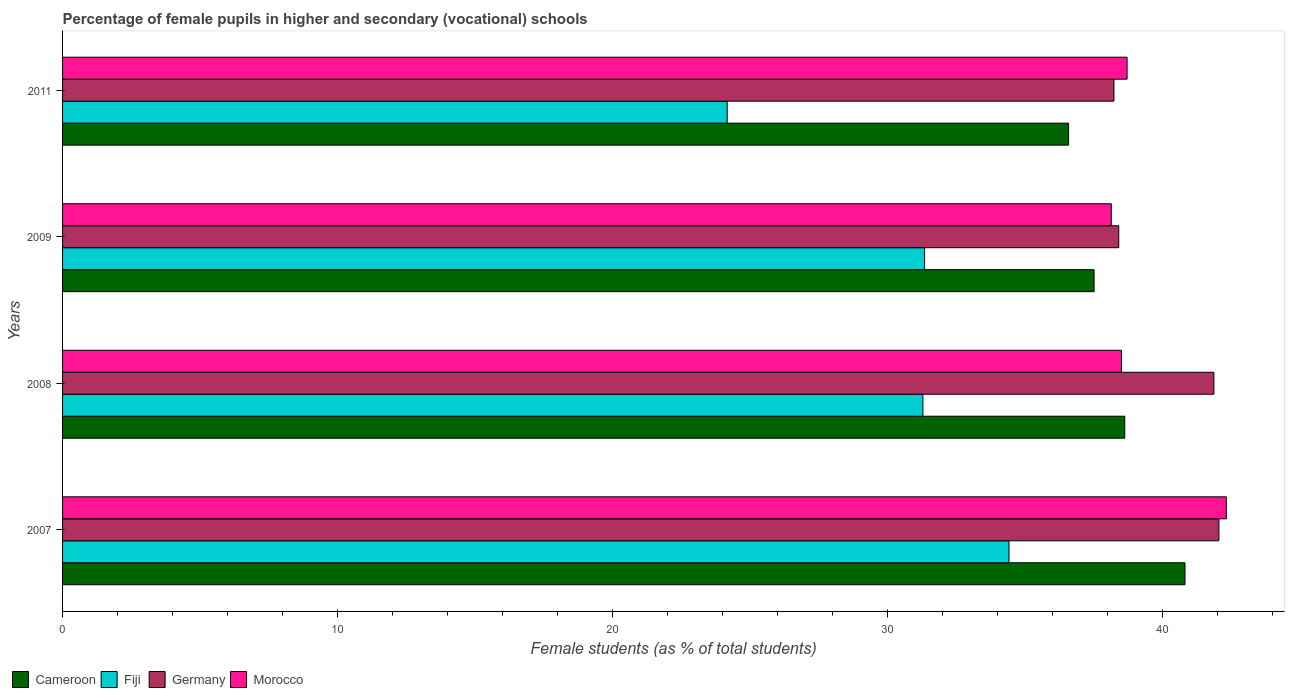How many different coloured bars are there?
Your response must be concise. 4. How many groups of bars are there?
Make the answer very short. 4. How many bars are there on the 1st tick from the bottom?
Offer a terse response. 4. In how many cases, is the number of bars for a given year not equal to the number of legend labels?
Provide a succinct answer. 0. What is the percentage of female pupils in higher and secondary schools in Germany in 2011?
Your answer should be very brief. 38.22. Across all years, what is the maximum percentage of female pupils in higher and secondary schools in Fiji?
Ensure brevity in your answer.  34.4. Across all years, what is the minimum percentage of female pupils in higher and secondary schools in Cameroon?
Ensure brevity in your answer.  36.57. What is the total percentage of female pupils in higher and secondary schools in Germany in the graph?
Make the answer very short. 160.5. What is the difference between the percentage of female pupils in higher and secondary schools in Morocco in 2009 and that in 2011?
Give a very brief answer. -0.57. What is the difference between the percentage of female pupils in higher and secondary schools in Fiji in 2009 and the percentage of female pupils in higher and secondary schools in Cameroon in 2007?
Provide a short and direct response. -9.47. What is the average percentage of female pupils in higher and secondary schools in Fiji per year?
Provide a short and direct response. 30.29. In the year 2007, what is the difference between the percentage of female pupils in higher and secondary schools in Germany and percentage of female pupils in higher and secondary schools in Cameroon?
Ensure brevity in your answer.  1.23. What is the ratio of the percentage of female pupils in higher and secondary schools in Morocco in 2007 to that in 2011?
Your answer should be very brief. 1.09. Is the percentage of female pupils in higher and secondary schools in Morocco in 2009 less than that in 2011?
Give a very brief answer. Yes. What is the difference between the highest and the second highest percentage of female pupils in higher and secondary schools in Fiji?
Provide a succinct answer. 3.07. What is the difference between the highest and the lowest percentage of female pupils in higher and secondary schools in Germany?
Provide a short and direct response. 3.82. What does the 1st bar from the top in 2007 represents?
Your answer should be compact. Morocco. What does the 4th bar from the bottom in 2007 represents?
Provide a succinct answer. Morocco. Is it the case that in every year, the sum of the percentage of female pupils in higher and secondary schools in Cameroon and percentage of female pupils in higher and secondary schools in Morocco is greater than the percentage of female pupils in higher and secondary schools in Germany?
Ensure brevity in your answer.  Yes. Are all the bars in the graph horizontal?
Offer a terse response. Yes. What is the difference between two consecutive major ticks on the X-axis?
Make the answer very short. 10. Are the values on the major ticks of X-axis written in scientific E-notation?
Give a very brief answer. No. How many legend labels are there?
Ensure brevity in your answer.  4. What is the title of the graph?
Keep it short and to the point. Percentage of female pupils in higher and secondary (vocational) schools. Does "Lower middle income" appear as one of the legend labels in the graph?
Provide a succinct answer. No. What is the label or title of the X-axis?
Your answer should be very brief. Female students (as % of total students). What is the label or title of the Y-axis?
Offer a terse response. Years. What is the Female students (as % of total students) of Cameroon in 2007?
Provide a short and direct response. 40.8. What is the Female students (as % of total students) in Fiji in 2007?
Your response must be concise. 34.4. What is the Female students (as % of total students) in Germany in 2007?
Ensure brevity in your answer.  42.04. What is the Female students (as % of total students) in Morocco in 2007?
Provide a succinct answer. 42.3. What is the Female students (as % of total students) in Cameroon in 2008?
Ensure brevity in your answer.  38.61. What is the Female students (as % of total students) in Fiji in 2008?
Provide a succinct answer. 31.27. What is the Female students (as % of total students) in Germany in 2008?
Your answer should be very brief. 41.85. What is the Female students (as % of total students) of Morocco in 2008?
Your response must be concise. 38.49. What is the Female students (as % of total students) of Cameroon in 2009?
Make the answer very short. 37.5. What is the Female students (as % of total students) of Fiji in 2009?
Your response must be concise. 31.34. What is the Female students (as % of total students) of Germany in 2009?
Make the answer very short. 38.39. What is the Female students (as % of total students) in Morocco in 2009?
Provide a short and direct response. 38.12. What is the Female students (as % of total students) of Cameroon in 2011?
Provide a short and direct response. 36.57. What is the Female students (as % of total students) of Fiji in 2011?
Provide a succinct answer. 24.16. What is the Female students (as % of total students) in Germany in 2011?
Give a very brief answer. 38.22. What is the Female students (as % of total students) in Morocco in 2011?
Your response must be concise. 38.7. Across all years, what is the maximum Female students (as % of total students) of Cameroon?
Make the answer very short. 40.8. Across all years, what is the maximum Female students (as % of total students) in Fiji?
Ensure brevity in your answer.  34.4. Across all years, what is the maximum Female students (as % of total students) in Germany?
Ensure brevity in your answer.  42.04. Across all years, what is the maximum Female students (as % of total students) of Morocco?
Provide a succinct answer. 42.3. Across all years, what is the minimum Female students (as % of total students) of Cameroon?
Ensure brevity in your answer.  36.57. Across all years, what is the minimum Female students (as % of total students) of Fiji?
Your response must be concise. 24.16. Across all years, what is the minimum Female students (as % of total students) in Germany?
Keep it short and to the point. 38.22. Across all years, what is the minimum Female students (as % of total students) in Morocco?
Your response must be concise. 38.12. What is the total Female students (as % of total students) of Cameroon in the graph?
Your answer should be compact. 153.48. What is the total Female students (as % of total students) of Fiji in the graph?
Offer a terse response. 121.18. What is the total Female students (as % of total students) of Germany in the graph?
Provide a short and direct response. 160.5. What is the total Female students (as % of total students) of Morocco in the graph?
Make the answer very short. 157.62. What is the difference between the Female students (as % of total students) in Cameroon in 2007 and that in 2008?
Your answer should be very brief. 2.19. What is the difference between the Female students (as % of total students) of Fiji in 2007 and that in 2008?
Provide a short and direct response. 3.13. What is the difference between the Female students (as % of total students) in Germany in 2007 and that in 2008?
Your response must be concise. 0.18. What is the difference between the Female students (as % of total students) in Morocco in 2007 and that in 2008?
Give a very brief answer. 3.81. What is the difference between the Female students (as % of total students) of Cameroon in 2007 and that in 2009?
Keep it short and to the point. 3.3. What is the difference between the Female students (as % of total students) in Fiji in 2007 and that in 2009?
Offer a very short reply. 3.07. What is the difference between the Female students (as % of total students) in Germany in 2007 and that in 2009?
Keep it short and to the point. 3.64. What is the difference between the Female students (as % of total students) in Morocco in 2007 and that in 2009?
Keep it short and to the point. 4.18. What is the difference between the Female students (as % of total students) in Cameroon in 2007 and that in 2011?
Offer a terse response. 4.23. What is the difference between the Female students (as % of total students) in Fiji in 2007 and that in 2011?
Ensure brevity in your answer.  10.24. What is the difference between the Female students (as % of total students) of Germany in 2007 and that in 2011?
Give a very brief answer. 3.82. What is the difference between the Female students (as % of total students) in Morocco in 2007 and that in 2011?
Ensure brevity in your answer.  3.61. What is the difference between the Female students (as % of total students) in Cameroon in 2008 and that in 2009?
Offer a terse response. 1.12. What is the difference between the Female students (as % of total students) of Fiji in 2008 and that in 2009?
Offer a terse response. -0.06. What is the difference between the Female students (as % of total students) of Germany in 2008 and that in 2009?
Your answer should be compact. 3.46. What is the difference between the Female students (as % of total students) of Morocco in 2008 and that in 2009?
Offer a terse response. 0.37. What is the difference between the Female students (as % of total students) of Cameroon in 2008 and that in 2011?
Your answer should be compact. 2.04. What is the difference between the Female students (as % of total students) in Fiji in 2008 and that in 2011?
Offer a terse response. 7.11. What is the difference between the Female students (as % of total students) of Germany in 2008 and that in 2011?
Offer a terse response. 3.63. What is the difference between the Female students (as % of total students) in Morocco in 2008 and that in 2011?
Make the answer very short. -0.2. What is the difference between the Female students (as % of total students) of Cameroon in 2009 and that in 2011?
Provide a short and direct response. 0.93. What is the difference between the Female students (as % of total students) in Fiji in 2009 and that in 2011?
Offer a terse response. 7.18. What is the difference between the Female students (as % of total students) of Germany in 2009 and that in 2011?
Provide a short and direct response. 0.17. What is the difference between the Female students (as % of total students) in Morocco in 2009 and that in 2011?
Provide a succinct answer. -0.57. What is the difference between the Female students (as % of total students) in Cameroon in 2007 and the Female students (as % of total students) in Fiji in 2008?
Offer a terse response. 9.53. What is the difference between the Female students (as % of total students) of Cameroon in 2007 and the Female students (as % of total students) of Germany in 2008?
Provide a short and direct response. -1.05. What is the difference between the Female students (as % of total students) of Cameroon in 2007 and the Female students (as % of total students) of Morocco in 2008?
Your response must be concise. 2.31. What is the difference between the Female students (as % of total students) of Fiji in 2007 and the Female students (as % of total students) of Germany in 2008?
Provide a succinct answer. -7.45. What is the difference between the Female students (as % of total students) of Fiji in 2007 and the Female students (as % of total students) of Morocco in 2008?
Your answer should be compact. -4.09. What is the difference between the Female students (as % of total students) of Germany in 2007 and the Female students (as % of total students) of Morocco in 2008?
Your answer should be very brief. 3.54. What is the difference between the Female students (as % of total students) of Cameroon in 2007 and the Female students (as % of total students) of Fiji in 2009?
Make the answer very short. 9.47. What is the difference between the Female students (as % of total students) of Cameroon in 2007 and the Female students (as % of total students) of Germany in 2009?
Your answer should be compact. 2.41. What is the difference between the Female students (as % of total students) of Cameroon in 2007 and the Female students (as % of total students) of Morocco in 2009?
Give a very brief answer. 2.68. What is the difference between the Female students (as % of total students) of Fiji in 2007 and the Female students (as % of total students) of Germany in 2009?
Offer a terse response. -3.99. What is the difference between the Female students (as % of total students) of Fiji in 2007 and the Female students (as % of total students) of Morocco in 2009?
Your answer should be very brief. -3.72. What is the difference between the Female students (as % of total students) in Germany in 2007 and the Female students (as % of total students) in Morocco in 2009?
Make the answer very short. 3.91. What is the difference between the Female students (as % of total students) of Cameroon in 2007 and the Female students (as % of total students) of Fiji in 2011?
Give a very brief answer. 16.64. What is the difference between the Female students (as % of total students) in Cameroon in 2007 and the Female students (as % of total students) in Germany in 2011?
Offer a terse response. 2.58. What is the difference between the Female students (as % of total students) in Cameroon in 2007 and the Female students (as % of total students) in Morocco in 2011?
Your response must be concise. 2.1. What is the difference between the Female students (as % of total students) of Fiji in 2007 and the Female students (as % of total students) of Germany in 2011?
Your response must be concise. -3.82. What is the difference between the Female students (as % of total students) in Fiji in 2007 and the Female students (as % of total students) in Morocco in 2011?
Offer a very short reply. -4.29. What is the difference between the Female students (as % of total students) in Germany in 2007 and the Female students (as % of total students) in Morocco in 2011?
Ensure brevity in your answer.  3.34. What is the difference between the Female students (as % of total students) in Cameroon in 2008 and the Female students (as % of total students) in Fiji in 2009?
Make the answer very short. 7.28. What is the difference between the Female students (as % of total students) in Cameroon in 2008 and the Female students (as % of total students) in Germany in 2009?
Offer a terse response. 0.22. What is the difference between the Female students (as % of total students) in Cameroon in 2008 and the Female students (as % of total students) in Morocco in 2009?
Ensure brevity in your answer.  0.49. What is the difference between the Female students (as % of total students) in Fiji in 2008 and the Female students (as % of total students) in Germany in 2009?
Your response must be concise. -7.12. What is the difference between the Female students (as % of total students) in Fiji in 2008 and the Female students (as % of total students) in Morocco in 2009?
Keep it short and to the point. -6.85. What is the difference between the Female students (as % of total students) in Germany in 2008 and the Female students (as % of total students) in Morocco in 2009?
Make the answer very short. 3.73. What is the difference between the Female students (as % of total students) of Cameroon in 2008 and the Female students (as % of total students) of Fiji in 2011?
Your answer should be very brief. 14.45. What is the difference between the Female students (as % of total students) of Cameroon in 2008 and the Female students (as % of total students) of Germany in 2011?
Your answer should be compact. 0.39. What is the difference between the Female students (as % of total students) in Cameroon in 2008 and the Female students (as % of total students) in Morocco in 2011?
Provide a succinct answer. -0.08. What is the difference between the Female students (as % of total students) of Fiji in 2008 and the Female students (as % of total students) of Germany in 2011?
Provide a succinct answer. -6.95. What is the difference between the Female students (as % of total students) in Fiji in 2008 and the Female students (as % of total students) in Morocco in 2011?
Offer a very short reply. -7.42. What is the difference between the Female students (as % of total students) of Germany in 2008 and the Female students (as % of total students) of Morocco in 2011?
Make the answer very short. 3.16. What is the difference between the Female students (as % of total students) of Cameroon in 2009 and the Female students (as % of total students) of Fiji in 2011?
Your answer should be very brief. 13.34. What is the difference between the Female students (as % of total students) of Cameroon in 2009 and the Female students (as % of total students) of Germany in 2011?
Your response must be concise. -0.72. What is the difference between the Female students (as % of total students) in Cameroon in 2009 and the Female students (as % of total students) in Morocco in 2011?
Give a very brief answer. -1.2. What is the difference between the Female students (as % of total students) in Fiji in 2009 and the Female students (as % of total students) in Germany in 2011?
Provide a short and direct response. -6.88. What is the difference between the Female students (as % of total students) of Fiji in 2009 and the Female students (as % of total students) of Morocco in 2011?
Offer a terse response. -7.36. What is the difference between the Female students (as % of total students) in Germany in 2009 and the Female students (as % of total students) in Morocco in 2011?
Give a very brief answer. -0.3. What is the average Female students (as % of total students) in Cameroon per year?
Ensure brevity in your answer.  38.37. What is the average Female students (as % of total students) in Fiji per year?
Provide a short and direct response. 30.29. What is the average Female students (as % of total students) in Germany per year?
Offer a very short reply. 40.13. What is the average Female students (as % of total students) of Morocco per year?
Keep it short and to the point. 39.4. In the year 2007, what is the difference between the Female students (as % of total students) in Cameroon and Female students (as % of total students) in Fiji?
Your response must be concise. 6.4. In the year 2007, what is the difference between the Female students (as % of total students) in Cameroon and Female students (as % of total students) in Germany?
Give a very brief answer. -1.23. In the year 2007, what is the difference between the Female students (as % of total students) of Cameroon and Female students (as % of total students) of Morocco?
Keep it short and to the point. -1.5. In the year 2007, what is the difference between the Female students (as % of total students) in Fiji and Female students (as % of total students) in Germany?
Provide a short and direct response. -7.63. In the year 2007, what is the difference between the Female students (as % of total students) in Fiji and Female students (as % of total students) in Morocco?
Provide a succinct answer. -7.9. In the year 2007, what is the difference between the Female students (as % of total students) in Germany and Female students (as % of total students) in Morocco?
Your response must be concise. -0.27. In the year 2008, what is the difference between the Female students (as % of total students) in Cameroon and Female students (as % of total students) in Fiji?
Your response must be concise. 7.34. In the year 2008, what is the difference between the Female students (as % of total students) in Cameroon and Female students (as % of total students) in Germany?
Keep it short and to the point. -3.24. In the year 2008, what is the difference between the Female students (as % of total students) in Cameroon and Female students (as % of total students) in Morocco?
Ensure brevity in your answer.  0.12. In the year 2008, what is the difference between the Female students (as % of total students) of Fiji and Female students (as % of total students) of Germany?
Ensure brevity in your answer.  -10.58. In the year 2008, what is the difference between the Female students (as % of total students) in Fiji and Female students (as % of total students) in Morocco?
Offer a very short reply. -7.22. In the year 2008, what is the difference between the Female students (as % of total students) in Germany and Female students (as % of total students) in Morocco?
Give a very brief answer. 3.36. In the year 2009, what is the difference between the Female students (as % of total students) in Cameroon and Female students (as % of total students) in Fiji?
Offer a terse response. 6.16. In the year 2009, what is the difference between the Female students (as % of total students) of Cameroon and Female students (as % of total students) of Germany?
Your answer should be very brief. -0.9. In the year 2009, what is the difference between the Female students (as % of total students) in Cameroon and Female students (as % of total students) in Morocco?
Your response must be concise. -0.63. In the year 2009, what is the difference between the Female students (as % of total students) of Fiji and Female students (as % of total students) of Germany?
Give a very brief answer. -7.06. In the year 2009, what is the difference between the Female students (as % of total students) in Fiji and Female students (as % of total students) in Morocco?
Make the answer very short. -6.79. In the year 2009, what is the difference between the Female students (as % of total students) in Germany and Female students (as % of total students) in Morocco?
Offer a terse response. 0.27. In the year 2011, what is the difference between the Female students (as % of total students) of Cameroon and Female students (as % of total students) of Fiji?
Your answer should be very brief. 12.41. In the year 2011, what is the difference between the Female students (as % of total students) in Cameroon and Female students (as % of total students) in Germany?
Keep it short and to the point. -1.65. In the year 2011, what is the difference between the Female students (as % of total students) in Cameroon and Female students (as % of total students) in Morocco?
Make the answer very short. -2.13. In the year 2011, what is the difference between the Female students (as % of total students) of Fiji and Female students (as % of total students) of Germany?
Your response must be concise. -14.06. In the year 2011, what is the difference between the Female students (as % of total students) of Fiji and Female students (as % of total students) of Morocco?
Offer a very short reply. -14.54. In the year 2011, what is the difference between the Female students (as % of total students) in Germany and Female students (as % of total students) in Morocco?
Your response must be concise. -0.48. What is the ratio of the Female students (as % of total students) of Cameroon in 2007 to that in 2008?
Your response must be concise. 1.06. What is the ratio of the Female students (as % of total students) in Fiji in 2007 to that in 2008?
Keep it short and to the point. 1.1. What is the ratio of the Female students (as % of total students) of Morocco in 2007 to that in 2008?
Your answer should be very brief. 1.1. What is the ratio of the Female students (as % of total students) in Cameroon in 2007 to that in 2009?
Provide a short and direct response. 1.09. What is the ratio of the Female students (as % of total students) of Fiji in 2007 to that in 2009?
Offer a terse response. 1.1. What is the ratio of the Female students (as % of total students) in Germany in 2007 to that in 2009?
Make the answer very short. 1.09. What is the ratio of the Female students (as % of total students) in Morocco in 2007 to that in 2009?
Ensure brevity in your answer.  1.11. What is the ratio of the Female students (as % of total students) in Cameroon in 2007 to that in 2011?
Make the answer very short. 1.12. What is the ratio of the Female students (as % of total students) in Fiji in 2007 to that in 2011?
Keep it short and to the point. 1.42. What is the ratio of the Female students (as % of total students) in Germany in 2007 to that in 2011?
Ensure brevity in your answer.  1.1. What is the ratio of the Female students (as % of total students) in Morocco in 2007 to that in 2011?
Provide a succinct answer. 1.09. What is the ratio of the Female students (as % of total students) of Cameroon in 2008 to that in 2009?
Ensure brevity in your answer.  1.03. What is the ratio of the Female students (as % of total students) in Fiji in 2008 to that in 2009?
Your answer should be compact. 1. What is the ratio of the Female students (as % of total students) in Germany in 2008 to that in 2009?
Keep it short and to the point. 1.09. What is the ratio of the Female students (as % of total students) of Morocco in 2008 to that in 2009?
Provide a short and direct response. 1.01. What is the ratio of the Female students (as % of total students) in Cameroon in 2008 to that in 2011?
Offer a terse response. 1.06. What is the ratio of the Female students (as % of total students) of Fiji in 2008 to that in 2011?
Offer a terse response. 1.29. What is the ratio of the Female students (as % of total students) in Germany in 2008 to that in 2011?
Provide a succinct answer. 1.1. What is the ratio of the Female students (as % of total students) of Cameroon in 2009 to that in 2011?
Provide a succinct answer. 1.03. What is the ratio of the Female students (as % of total students) of Fiji in 2009 to that in 2011?
Your answer should be compact. 1.3. What is the ratio of the Female students (as % of total students) of Germany in 2009 to that in 2011?
Give a very brief answer. 1. What is the ratio of the Female students (as % of total students) of Morocco in 2009 to that in 2011?
Offer a terse response. 0.99. What is the difference between the highest and the second highest Female students (as % of total students) in Cameroon?
Ensure brevity in your answer.  2.19. What is the difference between the highest and the second highest Female students (as % of total students) in Fiji?
Keep it short and to the point. 3.07. What is the difference between the highest and the second highest Female students (as % of total students) in Germany?
Provide a succinct answer. 0.18. What is the difference between the highest and the second highest Female students (as % of total students) in Morocco?
Your answer should be very brief. 3.61. What is the difference between the highest and the lowest Female students (as % of total students) of Cameroon?
Ensure brevity in your answer.  4.23. What is the difference between the highest and the lowest Female students (as % of total students) in Fiji?
Offer a terse response. 10.24. What is the difference between the highest and the lowest Female students (as % of total students) in Germany?
Offer a very short reply. 3.82. What is the difference between the highest and the lowest Female students (as % of total students) of Morocco?
Your response must be concise. 4.18. 